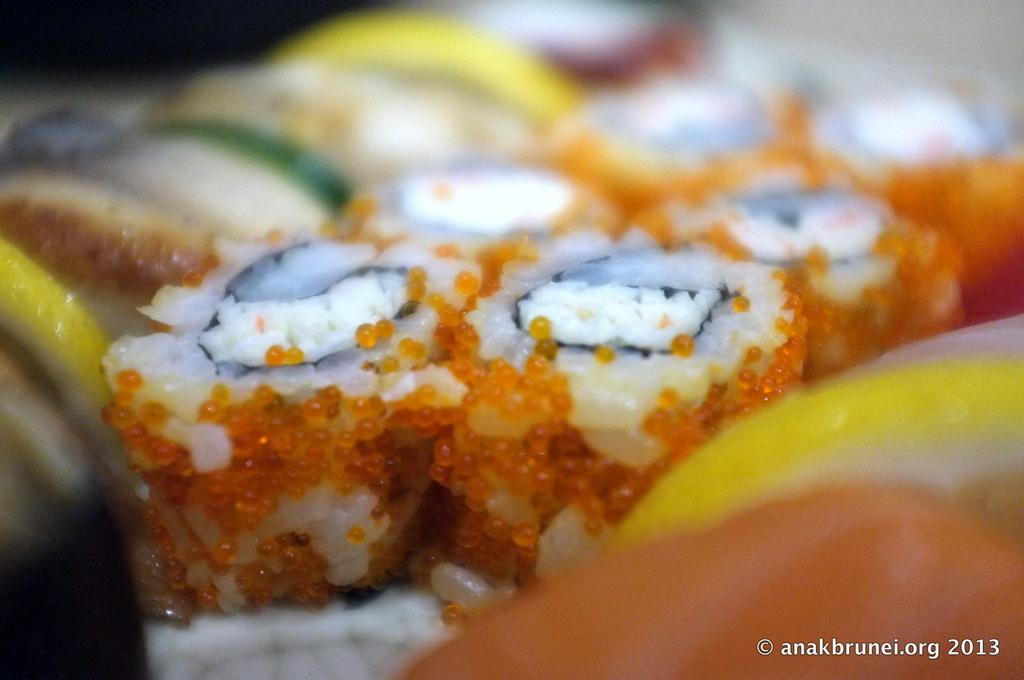What types of items can be seen in the image? There are food items in the image. Can you describe the background of the image? The background of the image is blurred. What type of fruit can be seen on the trail in the image? There is no trail or fruit present in the image; it only features food items with a blurred background. 